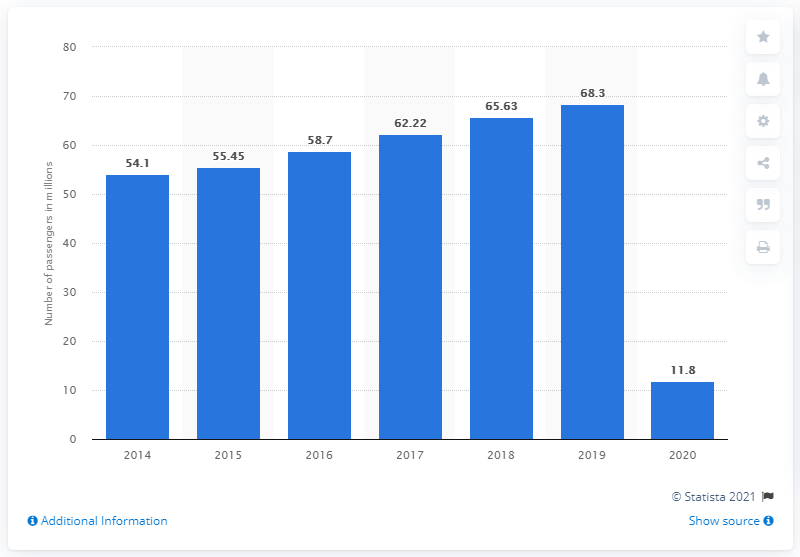Highlight a few significant elements in this photo. In 2019, Changi Airport welcomed a total of 68,305 visitors. In 2020, Changi Airport had 11.8 million visitors. 